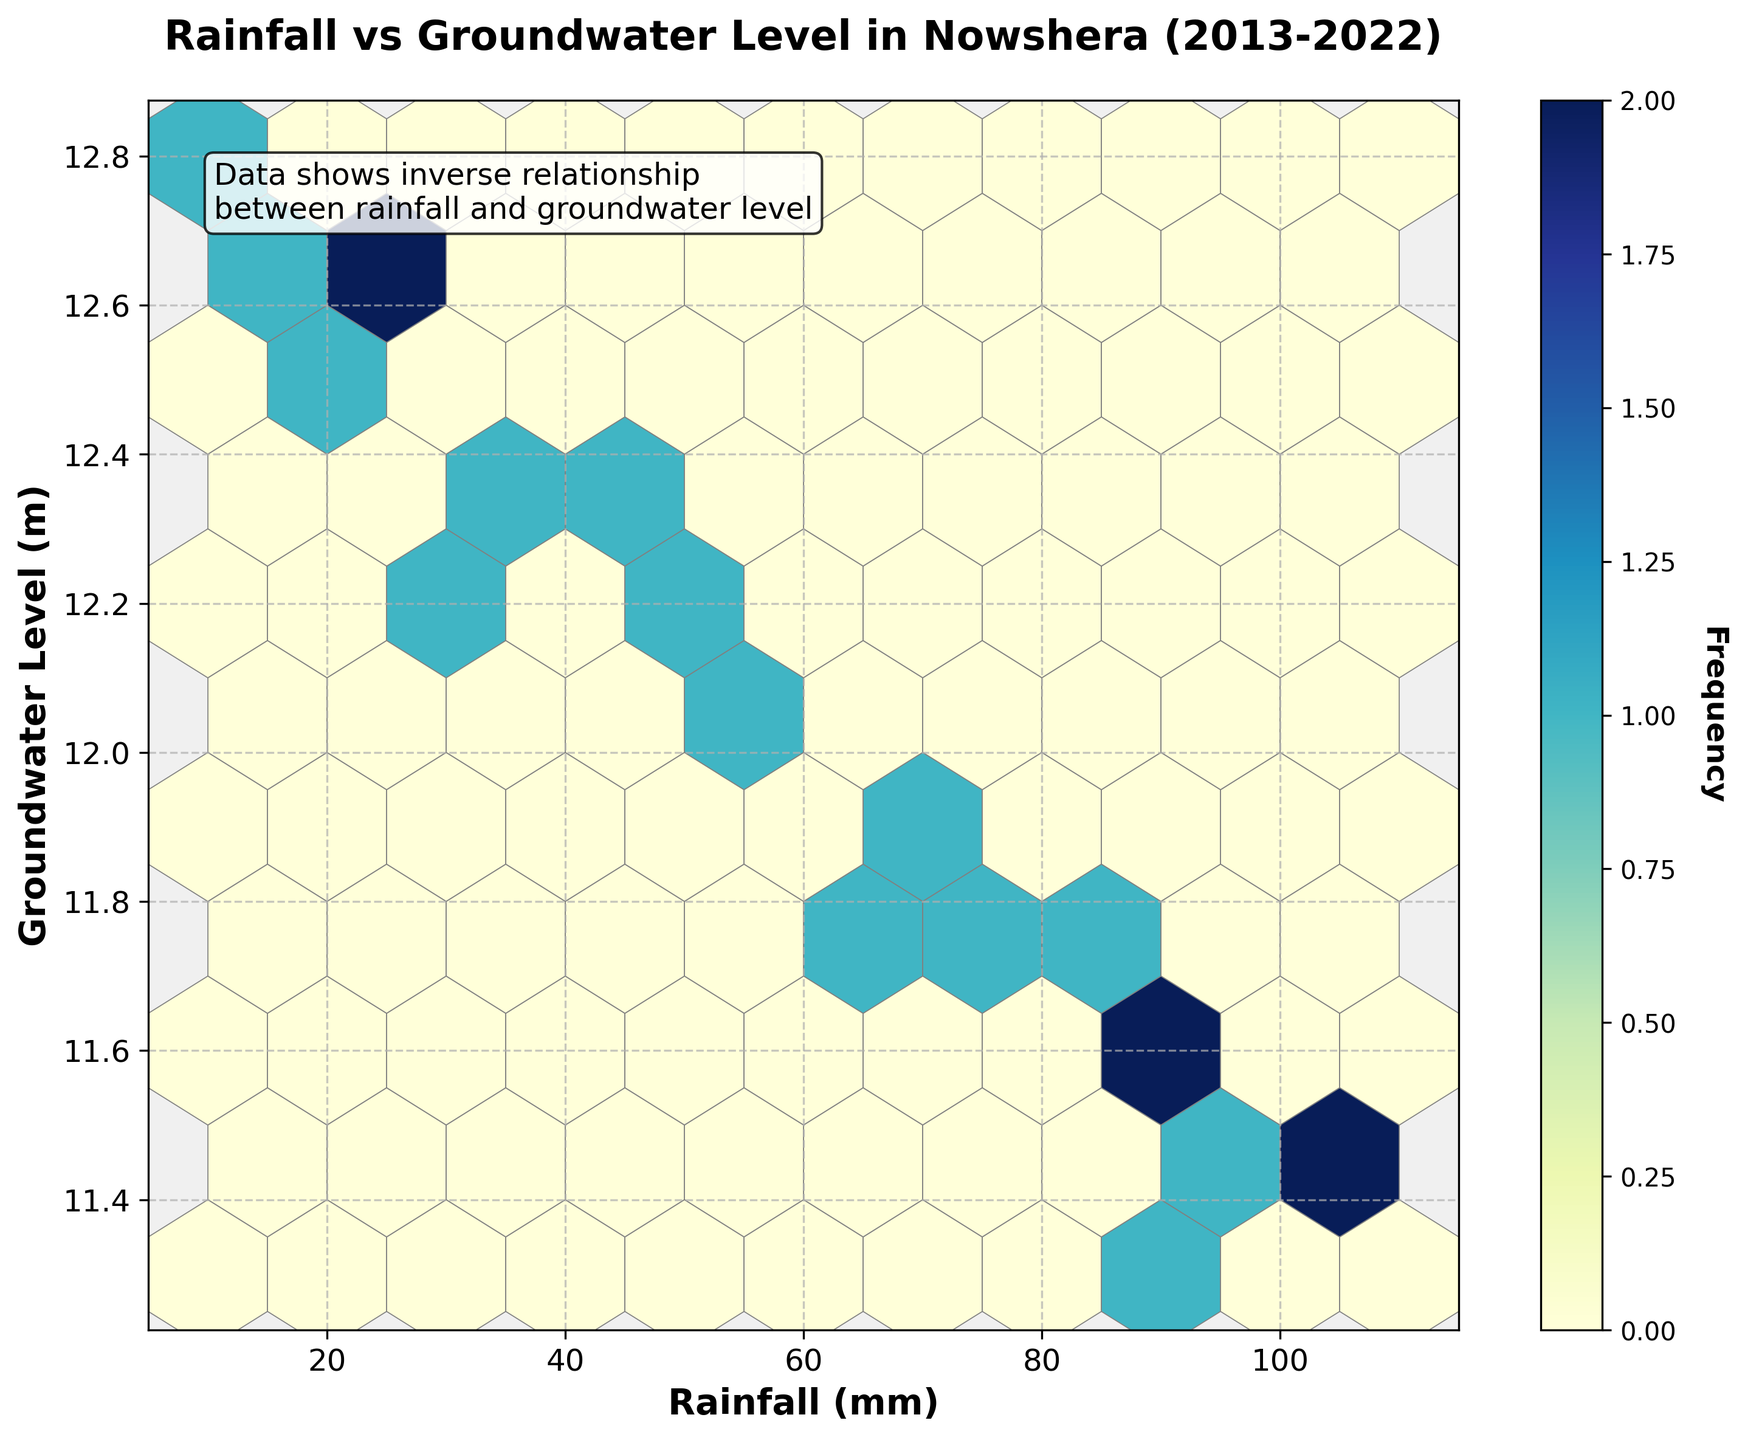What is the title of the plot? The title is usually located at the top of the plot and typically describes the main focus of the visual representation. By looking at the top of the figure, you can see the title mentioning the comparison between rainfall and groundwater levels in Nowshera.
Answer: Rainfall vs Groundwater Level in Nowshera (2013-2022) What do the x-axis and y-axis represent? The x-axis and y-axis labels explain what each axis measures. Looking at the labels, the x-axis represents Rainfall (in mm) and the y-axis denotes Groundwater Level (in meters).
Answer: Rainfall (mm) and Groundwater Level (m) How would you describe the color scheme of the hexbin plot? Observing the plot's color gradient helps you understand the frequency representation. The plot uses a color scheme that ranges from light yellow to dark blue. The color bar on the right indicates that darker colors represent higher frequencies of data points.
Answer: Light yellow to dark blue What does the text annotation inside the plot say? Text annotations are often used to highlight key insights. In this plot, the annotation is visible in the upper left quadrant and states that there is an inverse relationship between rainfall and groundwater levels.
Answer: Data shows inverse relationship between rainfall and groundwater level What is the general trend depicted in the Hexbin plot? By examining the distribution of data points represented by color density, the trend reveals that areas with higher rainfall tend to have lower groundwater levels and vice versa. This observation supports the text annotation about an inverse relationship.
Answer: Inverse relationship between rainfall and groundwater level What intervals are shown in the color bar and what do they represent? The color bar next to the plot shows intervals which indicate the frequency of data points within each hexbin cell. By looking closely at the color bar, you can see it ranges from light colors representing low frequencies to dark colors representing high frequencies.
Answer: Frequency of data points Which hexbin has the highest frequency, and what are its corresponding Rainfall and Groundwater Level values? Identifying the darkest hexbin indicates the highest frequency. By locating the darkest hexbin on the plot and checking its position, you can observe that the highest frequency is around Rainfall of 15-25 mm and Groundwater Level of approximately 12.7-12.8 meters.
Answer: Rainfall: 15-25 mm, Groundwater Level: 12.7-12.8 m Are there more data points with higher rainfall or lower rainfall? The density of hexbin colors can help identify this. Observing the plot, you notice there are more light-colored bins on the lower rainfall end compared to the higher rainfall end, indicating more data points with lower rainfall.
Answer: Lower rainfall Comparing 2013 to 2022, which year shows a lower average groundwater level? By aggregating the available data, you can estimate the average groundwater levels in these years and compare them. The Hexbin plot shows that generally, the groundwater levels were lower in the latter part of the decade, reflecting more rain received in recent years. Thus, comparing these temporal points will reveal that 2022 had slightly lower groundwater levels on average.
Answer: 2022 How does the frequency of data points change as rainfall increases? By examining the color distribution from left to right, you can see that darker hexbin clusters are more frequent in areas of low to moderate rainfall and fewer in high rainfall regions, meaning the frequency decreases as rainfall increases.
Answer: Decreases 